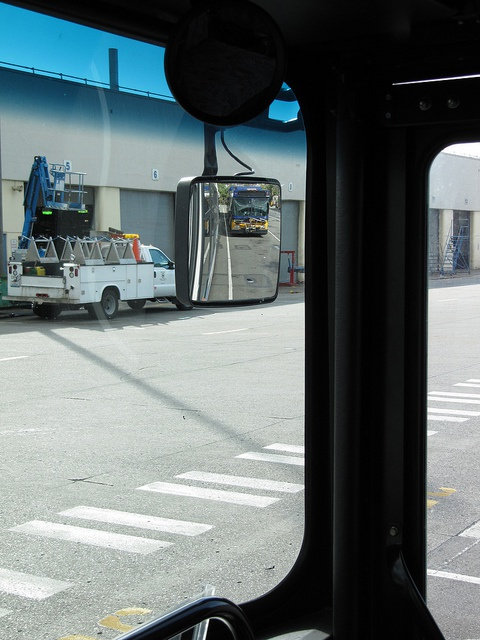Describe the objects in this image and their specific colors. I can see a truck in black, darkgray, gray, and lightblue tones in this image. 